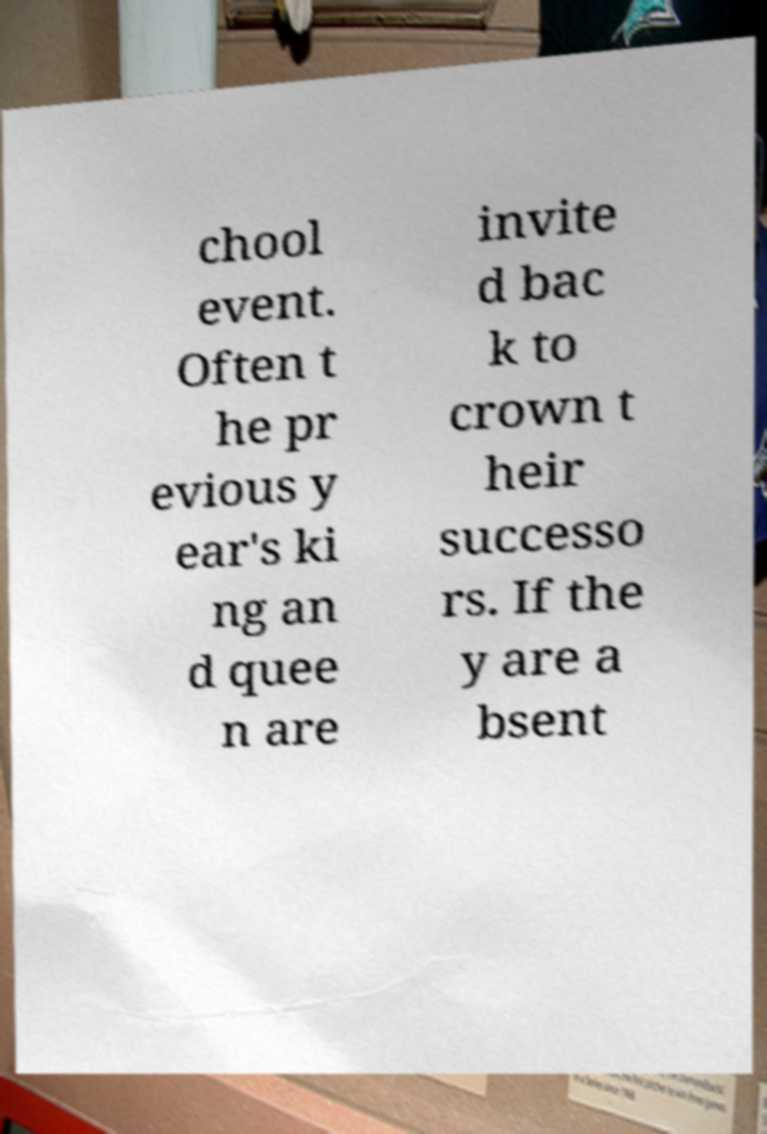Can you read and provide the text displayed in the image?This photo seems to have some interesting text. Can you extract and type it out for me? chool event. Often t he pr evious y ear's ki ng an d quee n are invite d bac k to crown t heir successo rs. If the y are a bsent 